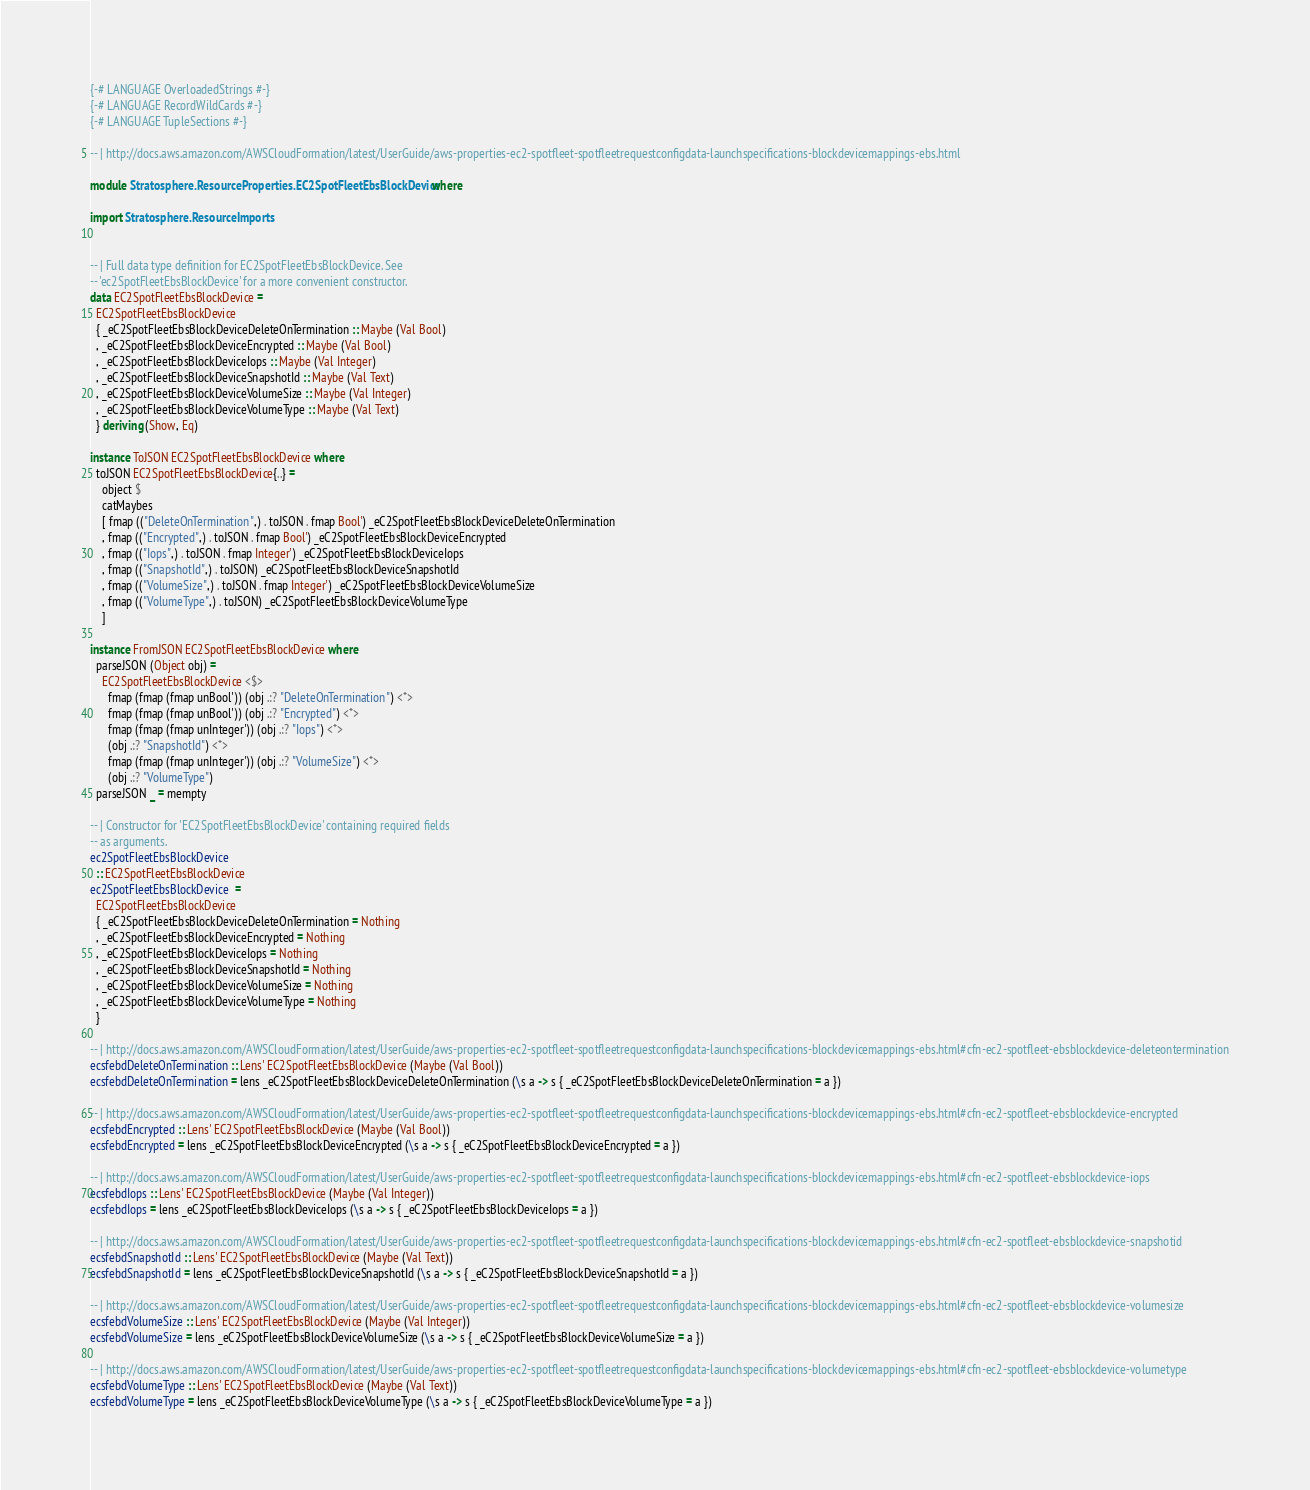Convert code to text. <code><loc_0><loc_0><loc_500><loc_500><_Haskell_>{-# LANGUAGE OverloadedStrings #-}
{-# LANGUAGE RecordWildCards #-}
{-# LANGUAGE TupleSections #-}

-- | http://docs.aws.amazon.com/AWSCloudFormation/latest/UserGuide/aws-properties-ec2-spotfleet-spotfleetrequestconfigdata-launchspecifications-blockdevicemappings-ebs.html

module Stratosphere.ResourceProperties.EC2SpotFleetEbsBlockDevice where

import Stratosphere.ResourceImports


-- | Full data type definition for EC2SpotFleetEbsBlockDevice. See
-- 'ec2SpotFleetEbsBlockDevice' for a more convenient constructor.
data EC2SpotFleetEbsBlockDevice =
  EC2SpotFleetEbsBlockDevice
  { _eC2SpotFleetEbsBlockDeviceDeleteOnTermination :: Maybe (Val Bool)
  , _eC2SpotFleetEbsBlockDeviceEncrypted :: Maybe (Val Bool)
  , _eC2SpotFleetEbsBlockDeviceIops :: Maybe (Val Integer)
  , _eC2SpotFleetEbsBlockDeviceSnapshotId :: Maybe (Val Text)
  , _eC2SpotFleetEbsBlockDeviceVolumeSize :: Maybe (Val Integer)
  , _eC2SpotFleetEbsBlockDeviceVolumeType :: Maybe (Val Text)
  } deriving (Show, Eq)

instance ToJSON EC2SpotFleetEbsBlockDevice where
  toJSON EC2SpotFleetEbsBlockDevice{..} =
    object $
    catMaybes
    [ fmap (("DeleteOnTermination",) . toJSON . fmap Bool') _eC2SpotFleetEbsBlockDeviceDeleteOnTermination
    , fmap (("Encrypted",) . toJSON . fmap Bool') _eC2SpotFleetEbsBlockDeviceEncrypted
    , fmap (("Iops",) . toJSON . fmap Integer') _eC2SpotFleetEbsBlockDeviceIops
    , fmap (("SnapshotId",) . toJSON) _eC2SpotFleetEbsBlockDeviceSnapshotId
    , fmap (("VolumeSize",) . toJSON . fmap Integer') _eC2SpotFleetEbsBlockDeviceVolumeSize
    , fmap (("VolumeType",) . toJSON) _eC2SpotFleetEbsBlockDeviceVolumeType
    ]

instance FromJSON EC2SpotFleetEbsBlockDevice where
  parseJSON (Object obj) =
    EC2SpotFleetEbsBlockDevice <$>
      fmap (fmap (fmap unBool')) (obj .:? "DeleteOnTermination") <*>
      fmap (fmap (fmap unBool')) (obj .:? "Encrypted") <*>
      fmap (fmap (fmap unInteger')) (obj .:? "Iops") <*>
      (obj .:? "SnapshotId") <*>
      fmap (fmap (fmap unInteger')) (obj .:? "VolumeSize") <*>
      (obj .:? "VolumeType")
  parseJSON _ = mempty

-- | Constructor for 'EC2SpotFleetEbsBlockDevice' containing required fields
-- as arguments.
ec2SpotFleetEbsBlockDevice
  :: EC2SpotFleetEbsBlockDevice
ec2SpotFleetEbsBlockDevice  =
  EC2SpotFleetEbsBlockDevice
  { _eC2SpotFleetEbsBlockDeviceDeleteOnTermination = Nothing
  , _eC2SpotFleetEbsBlockDeviceEncrypted = Nothing
  , _eC2SpotFleetEbsBlockDeviceIops = Nothing
  , _eC2SpotFleetEbsBlockDeviceSnapshotId = Nothing
  , _eC2SpotFleetEbsBlockDeviceVolumeSize = Nothing
  , _eC2SpotFleetEbsBlockDeviceVolumeType = Nothing
  }

-- | http://docs.aws.amazon.com/AWSCloudFormation/latest/UserGuide/aws-properties-ec2-spotfleet-spotfleetrequestconfigdata-launchspecifications-blockdevicemappings-ebs.html#cfn-ec2-spotfleet-ebsblockdevice-deleteontermination
ecsfebdDeleteOnTermination :: Lens' EC2SpotFleetEbsBlockDevice (Maybe (Val Bool))
ecsfebdDeleteOnTermination = lens _eC2SpotFleetEbsBlockDeviceDeleteOnTermination (\s a -> s { _eC2SpotFleetEbsBlockDeviceDeleteOnTermination = a })

-- | http://docs.aws.amazon.com/AWSCloudFormation/latest/UserGuide/aws-properties-ec2-spotfleet-spotfleetrequestconfigdata-launchspecifications-blockdevicemappings-ebs.html#cfn-ec2-spotfleet-ebsblockdevice-encrypted
ecsfebdEncrypted :: Lens' EC2SpotFleetEbsBlockDevice (Maybe (Val Bool))
ecsfebdEncrypted = lens _eC2SpotFleetEbsBlockDeviceEncrypted (\s a -> s { _eC2SpotFleetEbsBlockDeviceEncrypted = a })

-- | http://docs.aws.amazon.com/AWSCloudFormation/latest/UserGuide/aws-properties-ec2-spotfleet-spotfleetrequestconfigdata-launchspecifications-blockdevicemappings-ebs.html#cfn-ec2-spotfleet-ebsblockdevice-iops
ecsfebdIops :: Lens' EC2SpotFleetEbsBlockDevice (Maybe (Val Integer))
ecsfebdIops = lens _eC2SpotFleetEbsBlockDeviceIops (\s a -> s { _eC2SpotFleetEbsBlockDeviceIops = a })

-- | http://docs.aws.amazon.com/AWSCloudFormation/latest/UserGuide/aws-properties-ec2-spotfleet-spotfleetrequestconfigdata-launchspecifications-blockdevicemappings-ebs.html#cfn-ec2-spotfleet-ebsblockdevice-snapshotid
ecsfebdSnapshotId :: Lens' EC2SpotFleetEbsBlockDevice (Maybe (Val Text))
ecsfebdSnapshotId = lens _eC2SpotFleetEbsBlockDeviceSnapshotId (\s a -> s { _eC2SpotFleetEbsBlockDeviceSnapshotId = a })

-- | http://docs.aws.amazon.com/AWSCloudFormation/latest/UserGuide/aws-properties-ec2-spotfleet-spotfleetrequestconfigdata-launchspecifications-blockdevicemappings-ebs.html#cfn-ec2-spotfleet-ebsblockdevice-volumesize
ecsfebdVolumeSize :: Lens' EC2SpotFleetEbsBlockDevice (Maybe (Val Integer))
ecsfebdVolumeSize = lens _eC2SpotFleetEbsBlockDeviceVolumeSize (\s a -> s { _eC2SpotFleetEbsBlockDeviceVolumeSize = a })

-- | http://docs.aws.amazon.com/AWSCloudFormation/latest/UserGuide/aws-properties-ec2-spotfleet-spotfleetrequestconfigdata-launchspecifications-blockdevicemappings-ebs.html#cfn-ec2-spotfleet-ebsblockdevice-volumetype
ecsfebdVolumeType :: Lens' EC2SpotFleetEbsBlockDevice (Maybe (Val Text))
ecsfebdVolumeType = lens _eC2SpotFleetEbsBlockDeviceVolumeType (\s a -> s { _eC2SpotFleetEbsBlockDeviceVolumeType = a })
</code> 